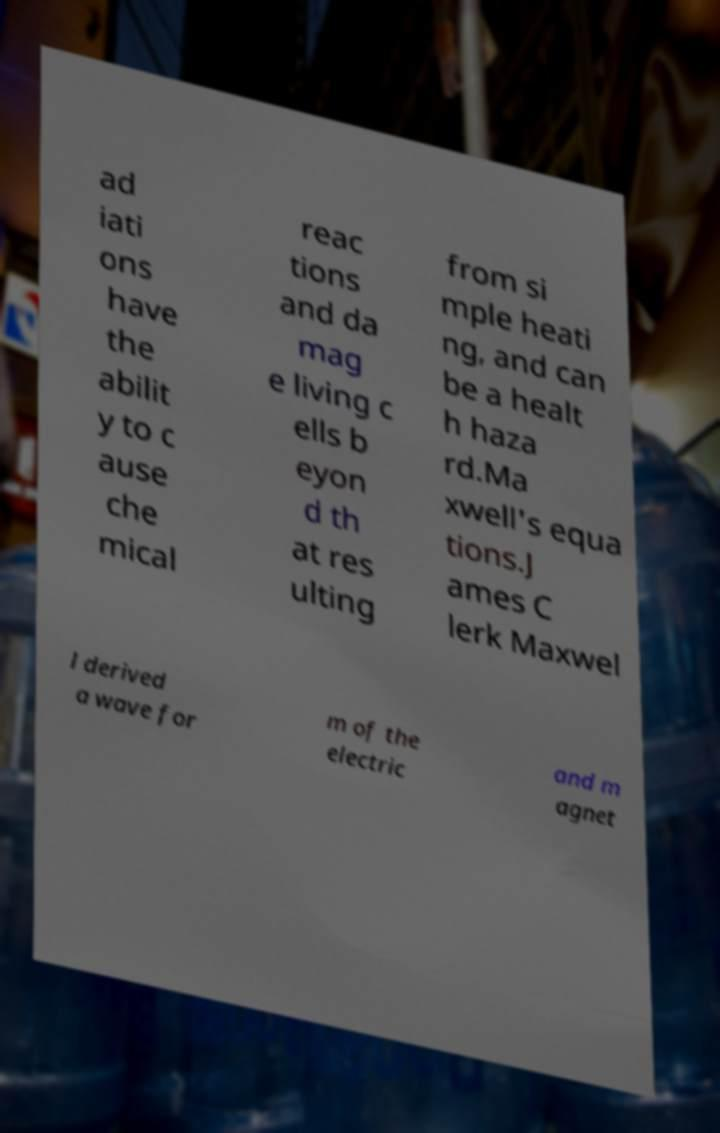Could you assist in decoding the text presented in this image and type it out clearly? ad iati ons have the abilit y to c ause che mical reac tions and da mag e living c ells b eyon d th at res ulting from si mple heati ng, and can be a healt h haza rd.Ma xwell's equa tions.J ames C lerk Maxwel l derived a wave for m of the electric and m agnet 